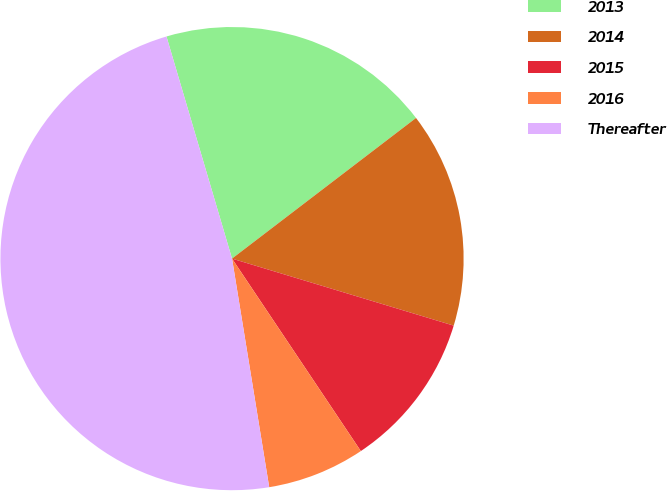Convert chart. <chart><loc_0><loc_0><loc_500><loc_500><pie_chart><fcel>2013<fcel>2014<fcel>2015<fcel>2016<fcel>Thereafter<nl><fcel>19.18%<fcel>15.06%<fcel>10.94%<fcel>6.82%<fcel>48.0%<nl></chart> 